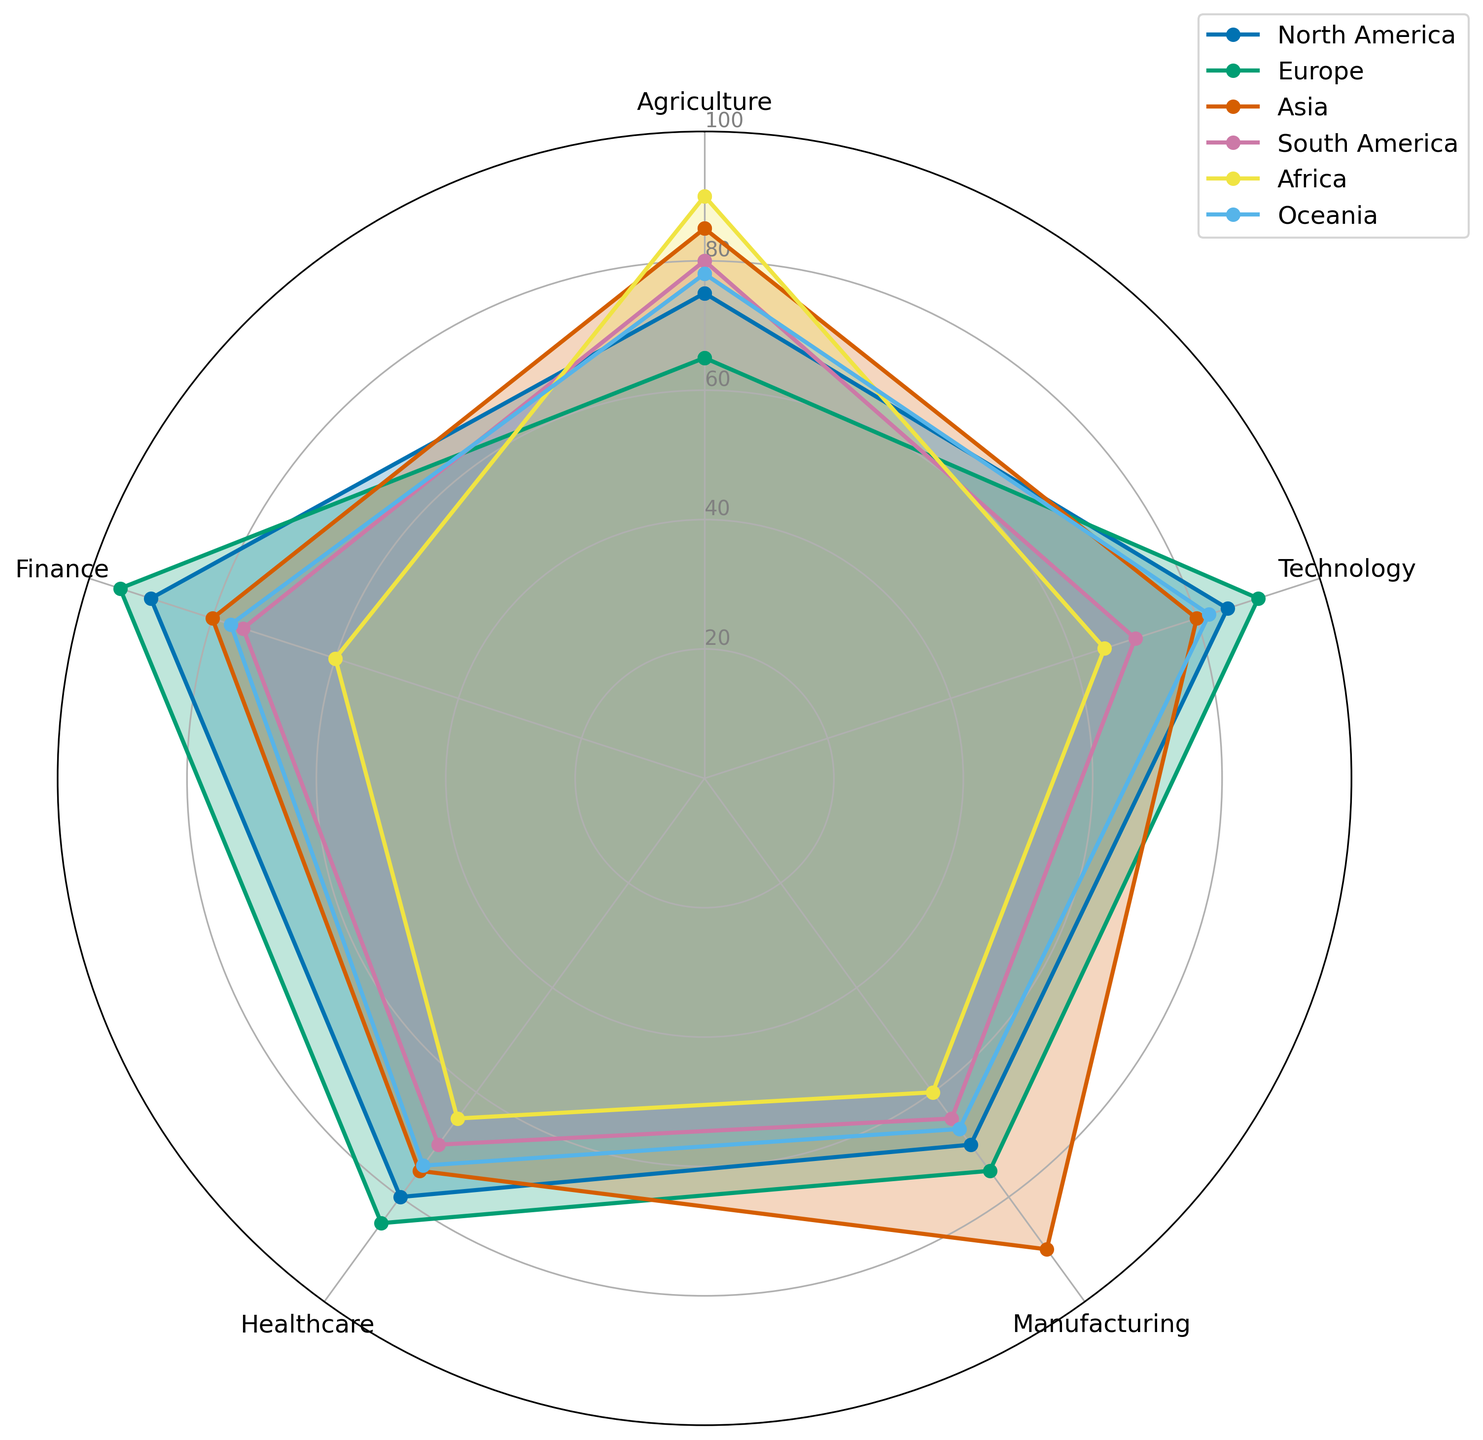Which region has the highest contribution in the Finance sector? Look at the sectors labeled "Finance" on the radar chart and compare the height of the plotted points for each region. The highest point represents the highest contribution.
Answer: Europe Which region has the lowest contribution in the Agriculture sector? Look at the sectors labeled "Agriculture" on the radar chart and compare the height of the plotted points for each region. The lowest point represents the lowest contribution.
Answer: Africa How does North America's contribution in Technology compare to that of Asia? Compare the heights of the data points for North America and Asia in the Technology sector. North America's plot point is higher than Asia's.
Answer: North America has a higher contribution What is the average value of contributions across all sectors for South America? Sum up the values for South America across all sectors: (80 + 70 + 65 + 70 + 75) = 360, and then divide by the number of sectors (5). 360/5 = 72
Answer: 72 Between Europe and Oceania, which region has a higher average contribution in the Manufacturing and Technology sectors combined? Calculate the average for both sectors combined for Europe: (75 + 90)/2 = 82.5 and for Oceania: (67 + 82)/2 = 74.5. Compare the two averages.
Answer: Europe In which sector does Asia have the highest contribution and what is the value? Look at the plotted points for Asia in each sector and identify the highest one. The highest point is in Manufacturing with a value of 90.
Answer: Manufacturing, 90 Is the Healthcare sector contribution for Africa higher or lower than that of South America? Compare the heights of the plotted points for Africa and South America in the Healthcare sector. Africa's plot point is at 65, and South America's is at 70.
Answer: Lower How much greater is the Finance contribution of Oceania compared to that of Africa? Subtract the Finance value for Africa (60) from the Finance value for Oceania (77). 77 - 60 = 17
Answer: 17 What is the difference between the maximum and minimum contribution values for all sectors across all regions? Identify the maximum (95 for Europe in Finance) and minimum (60 for two instances: Africa in Manufacturing and Finance) values across all sectors and regions. Subtract the minimum from the maximum. 95 - 60 = 35
Answer: 35 Which region has the most uniform distribution of contributions across all sectors? Observe the radar chart and look for the region whose plotted points form the most uniform or consistent shape. North America and Oceania are relatively uniform, so this requires judgment.
Answer: North America or Oceania 